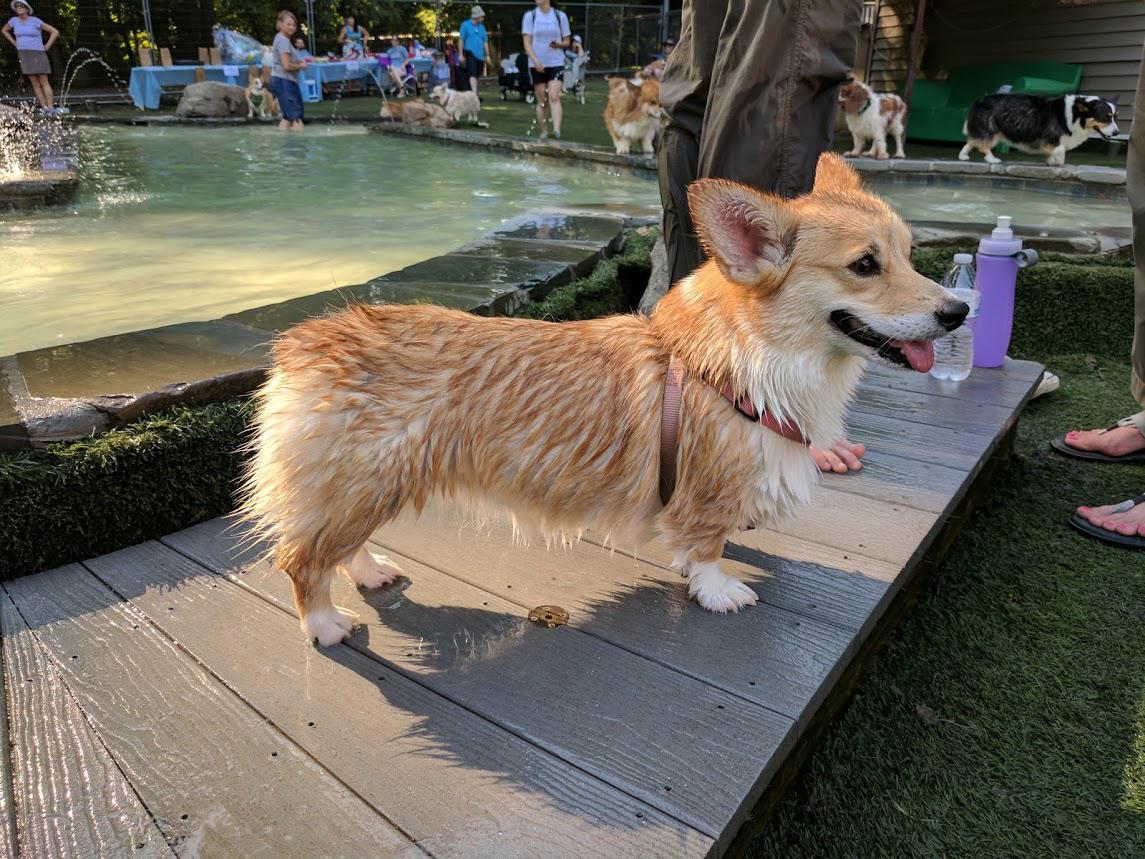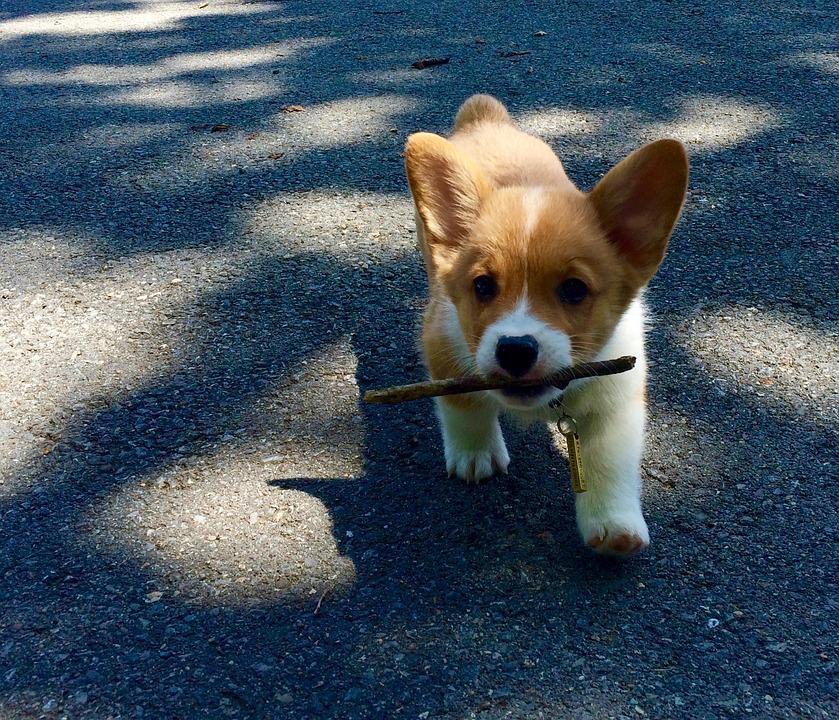The first image is the image on the left, the second image is the image on the right. Assess this claim about the two images: "One image shows at least one dog swimming forward with nothing carried in its mouth, and the other image contains one sitting dog wearing a leash.". Correct or not? Answer yes or no. No. The first image is the image on the left, the second image is the image on the right. Assess this claim about the two images: "One of the dogs has a stick in its mouth.". Correct or not? Answer yes or no. Yes. 